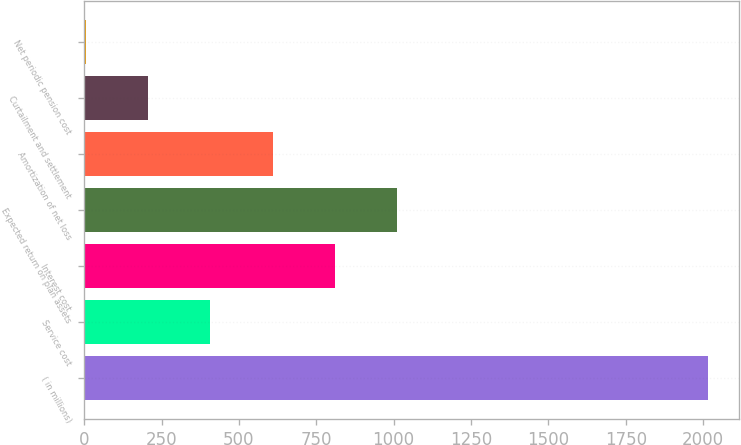Convert chart. <chart><loc_0><loc_0><loc_500><loc_500><bar_chart><fcel>( in millions)<fcel>Service cost<fcel>Interest cost<fcel>Expected return on plan assets<fcel>Amortization of net loss<fcel>Curtailment and settlement<fcel>Net periodic pension cost<nl><fcel>2015<fcel>407.56<fcel>809.42<fcel>1010.35<fcel>608.49<fcel>206.63<fcel>5.7<nl></chart> 